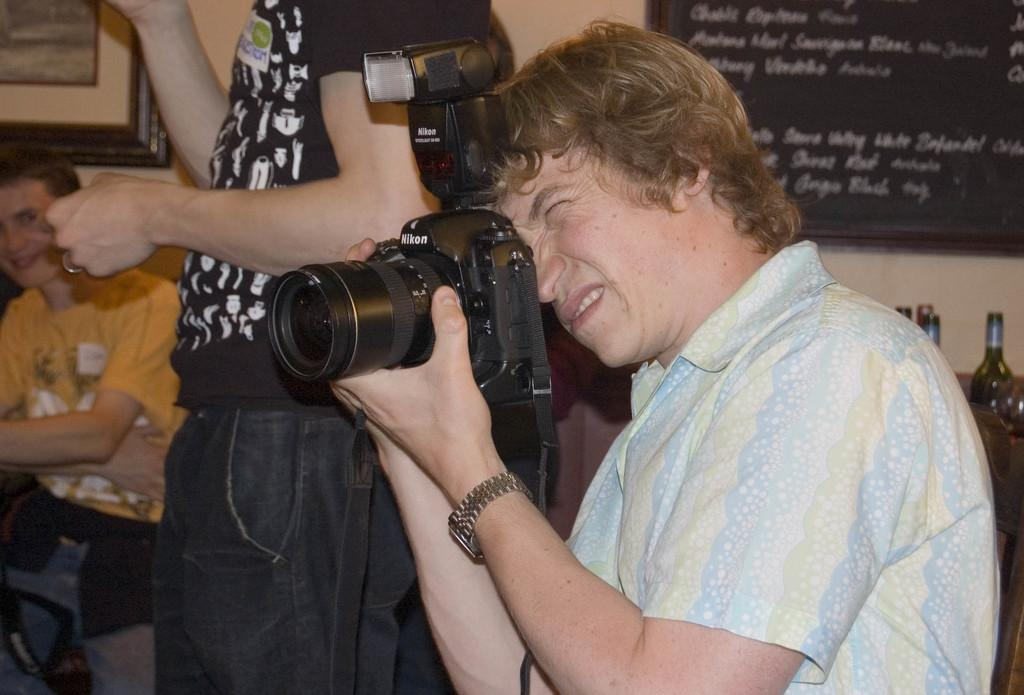What is the person in the image holding? The person in the image is holding a camera. Can you describe the other person in the image? There is another person standing nearby. What can be seen in the background of the image? There is a wall in the image. What is attached to the wall? Photo frames are present on the wall. Is the person holding the camera a spy in the image? There is no indication in the image that the person holding the camera is a spy. Can you see any smoke coming from the wall in the image? There is no smoke present in the image. 